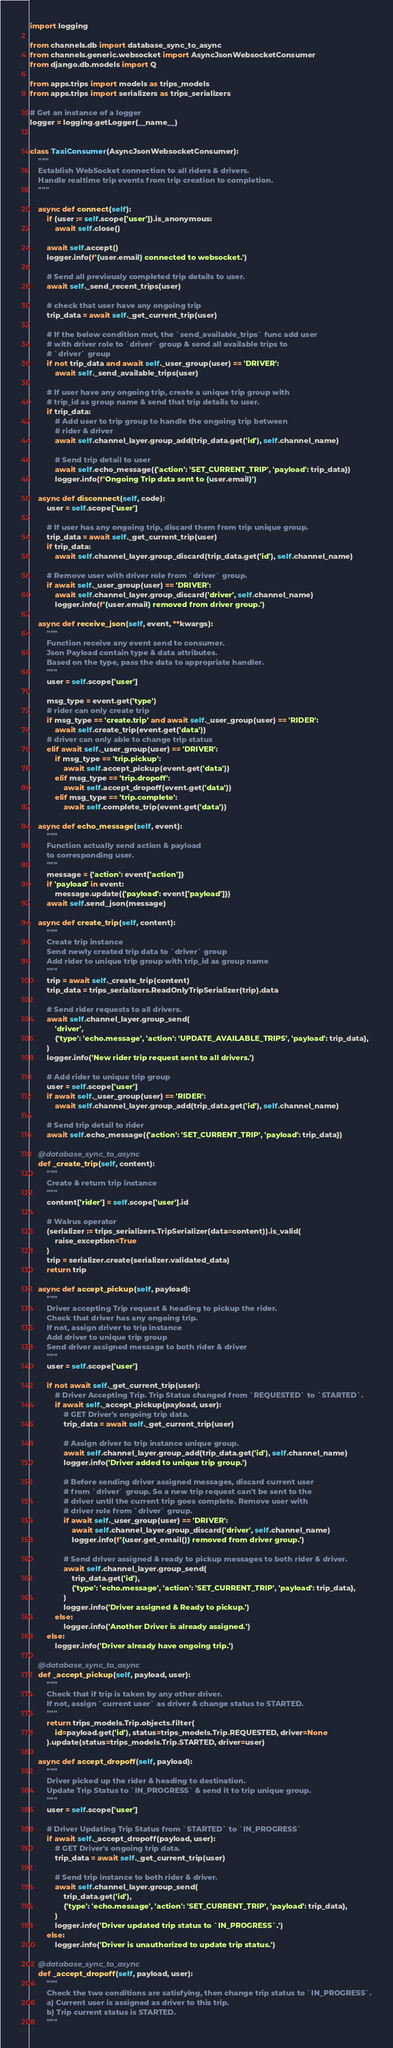Convert code to text. <code><loc_0><loc_0><loc_500><loc_500><_Python_>import logging

from channels.db import database_sync_to_async
from channels.generic.websocket import AsyncJsonWebsocketConsumer
from django.db.models import Q

from apps.trips import models as trips_models
from apps.trips import serializers as trips_serializers

# Get an instance of a logger
logger = logging.getLogger(__name__)


class TaxiConsumer(AsyncJsonWebsocketConsumer):
    """
    Establish WebSocket connection to all riders & drivers.
    Handle realtime trip events from trip creation to completion.
    """

    async def connect(self):
        if (user := self.scope['user']).is_anonymous:
            await self.close()

        await self.accept()
        logger.info(f'{user.email} connected to websocket.')

        # Send all previously completed trip details to user.
        await self._send_recent_trips(user)

        # check that user have any ongoing trip
        trip_data = await self._get_current_trip(user)

        # If the below condition met, the `send_available_trips` func add user
        # with driver role to `driver` group & send all available trips to
        # `driver` group
        if not trip_data and await self._user_group(user) == 'DRIVER':
            await self._send_available_trips(user)

        # If user have any ongoing trip, create a unique trip group with
        # trip_id as group name & send that trip details to user.
        if trip_data:
            # Add user to trip group to handle the ongoing trip between
            # rider & driver
            await self.channel_layer.group_add(trip_data.get('id'), self.channel_name)

            # Send trip detail to user
            await self.echo_message({'action': 'SET_CURRENT_TRIP', 'payload': trip_data})
            logger.info(f'Ongoing Trip data sent to {user.email}')

    async def disconnect(self, code):
        user = self.scope['user']

        # If user has any ongoing trip, discard them from trip unique group.
        trip_data = await self._get_current_trip(user)
        if trip_data:
            await self.channel_layer.group_discard(trip_data.get('id'), self.channel_name)

        # Remove user with driver role from `driver` group.
        if await self._user_group(user) == 'DRIVER':
            await self.channel_layer.group_discard('driver', self.channel_name)
            logger.info(f'{user.email} removed from driver group.')

    async def receive_json(self, event, **kwargs):
        """
        Function receive any event send to consumer.
        Json Payload contain type & data attributes.
        Based on the type, pass the data to appropriate handler.
        """
        user = self.scope['user']

        msg_type = event.get('type')
        # rider can only create trip
        if msg_type == 'create.trip' and await self._user_group(user) == 'RIDER':
            await self.create_trip(event.get('data'))
        # driver can only able to change trip status
        elif await self._user_group(user) == 'DRIVER':
            if msg_type == 'trip.pickup':
                await self.accept_pickup(event.get('data'))
            elif msg_type == 'trip.dropoff':
                await self.accept_dropoff(event.get('data'))
            elif msg_type == 'trip.complete':
                await self.complete_trip(event.get('data'))

    async def echo_message(self, event):
        """
        Function actually send action & payload
        to corresponding user.
        """
        message = {'action': event['action']}
        if 'payload' in event:
            message.update({'payload': event['payload']})
        await self.send_json(message)

    async def create_trip(self, content):
        """
        Create trip instance
        Send newly created trip data to `driver` group
        Add rider to unique trip group with trip_id as group name
        """
        trip = await self._create_trip(content)
        trip_data = trips_serializers.ReadOnlyTripSerializer(trip).data

        # Send rider requests to all drivers.
        await self.channel_layer.group_send(
            'driver',
            {'type': 'echo.message', 'action': 'UPDATE_AVAILABLE_TRIPS', 'payload': trip_data},
        )
        logger.info('New rider trip request sent to all drivers.')

        # Add rider to unique trip group
        user = self.scope['user']
        if await self._user_group(user) == 'RIDER':
            await self.channel_layer.group_add(trip_data.get('id'), self.channel_name)

        # Send trip detail to rider
        await self.echo_message({'action': 'SET_CURRENT_TRIP', 'payload': trip_data})

    @database_sync_to_async
    def _create_trip(self, content):
        """
        Create & return trip instance
        """
        content['rider'] = self.scope['user'].id

        # Walrus operator
        (serializer := trips_serializers.TripSerializer(data=content)).is_valid(
            raise_exception=True
        )
        trip = serializer.create(serializer.validated_data)
        return trip

    async def accept_pickup(self, payload):
        """
        Driver accepting Trip request & heading to pickup the rider.
        Check that driver has any ongoing trip.
        If not, assign driver to trip instance
        Add driver to unique trip group
        Send driver assigned message to both rider & driver
        """
        user = self.scope['user']

        if not await self._get_current_trip(user):
            # Driver Accepting Trip. Trip Status changed from `REQUESTED` to `STARTED`.
            if await self._accept_pickup(payload, user):
                # GET Driver's ongoing trip data.
                trip_data = await self._get_current_trip(user)

                # Assign driver to trip instance unique group.
                await self.channel_layer.group_add(trip_data.get('id'), self.channel_name)
                logger.info('Driver added to unique trip group.')

                # Before sending driver assigned messages, discard current user
                # from `driver` group. So a new trip request can't be sent to the
                # driver until the current trip goes complete. Remove user with
                # driver role from `driver` group.
                if await self._user_group(user) == 'DRIVER':
                    await self.channel_layer.group_discard('driver', self.channel_name)
                    logger.info(f'{user.get_email()} removed from driver group.')

                # Send driver assigned & ready to pickup messages to both rider & driver.
                await self.channel_layer.group_send(
                    trip_data.get('id'),
                    {'type': 'echo.message', 'action': 'SET_CURRENT_TRIP', 'payload': trip_data},
                )
                logger.info('Driver assigned & Ready to pickup.')
            else:
                logger.info('Another Driver is already assigned.')
        else:
            logger.info('Driver already have ongoing trip.')

    @database_sync_to_async
    def _accept_pickup(self, payload, user):
        """
        Check that if trip is taken by any other driver.
        If not, assign `current user` as driver & change status to STARTED.
        """
        return trips_models.Trip.objects.filter(
            id=payload.get('id'), status=trips_models.Trip.REQUESTED, driver=None
        ).update(status=trips_models.Trip.STARTED, driver=user)

    async def accept_dropoff(self, payload):
        """
        Driver picked up the rider & heading to destination.
        Update Trip Status to `IN_PROGRESS` & send it to trip unique group.
        """
        user = self.scope['user']

        # Driver Updating Trip Status from `STARTED` to `IN_PROGRESS`
        if await self._accept_dropoff(payload, user):
            # GET Driver's ongoing trip data.
            trip_data = await self._get_current_trip(user)

            # Send trip instance to both rider & driver.
            await self.channel_layer.group_send(
                trip_data.get('id'),
                {'type': 'echo.message', 'action': 'SET_CURRENT_TRIP', 'payload': trip_data},
            )
            logger.info('Driver updated trip status to `IN_PROGRESS`.')
        else:
            logger.info('Driver is unauthorized to update trip status.')

    @database_sync_to_async
    def _accept_dropoff(self, payload, user):
        """
        Check the two conditions are satisfying, then change trip status to `IN_PROGRESS`.
        a) Current user is assigned as driver to this trip.
        b) Trip current status is STARTED.
        """</code> 